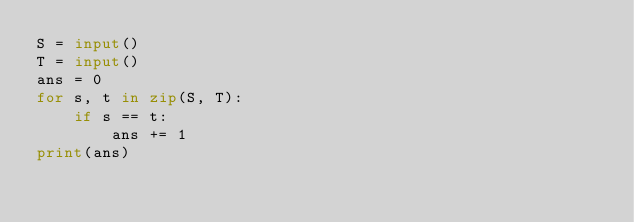Convert code to text. <code><loc_0><loc_0><loc_500><loc_500><_Python_>S = input()
T = input()
ans = 0
for s, t in zip(S, T):
    if s == t:
        ans += 1 
print(ans)</code> 